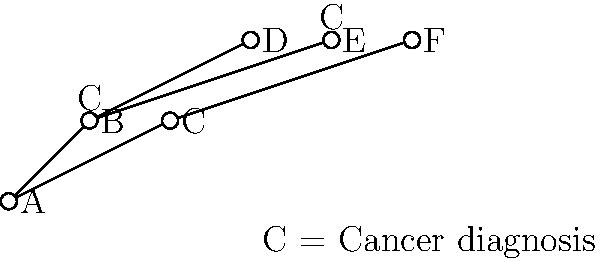Given the family tree diagram above, where 'C' indicates a cancer diagnosis, what is the probability that individual F will develop cancer, assuming a simple genetic model where having a parent with cancer doubles the baseline risk of 10%? To solve this problem, we'll follow these steps:

1. Identify F's position in the family tree:
   F is a child of C, who does not have a cancer diagnosis.

2. Determine the baseline risk:
   The baseline risk is given as 10% or 0.1.

3. Assess the impact of family history:
   - F's parent (C) does not have cancer, so there's no direct increase in risk.
   - F's grandparent (A) also does not have cancer.
   - However, F's aunt (B) has cancer, which could indicate some genetic predisposition in the family.

4. Apply the genetic model:
   - Since F's parent doesn't have cancer, we don't double the risk.
   - The presence of cancer in an aunt (B) suggests a potential genetic factor, but it doesn't directly affect F's risk according to the given model.

5. Calculate the probability:
   - Without direct parental cancer, F's risk remains at the baseline of 10%.

Therefore, based on the given simple genetic model and the information provided in the family tree, F's probability of developing cancer remains at the baseline risk of 10% or 0.1.
Answer: 10% 